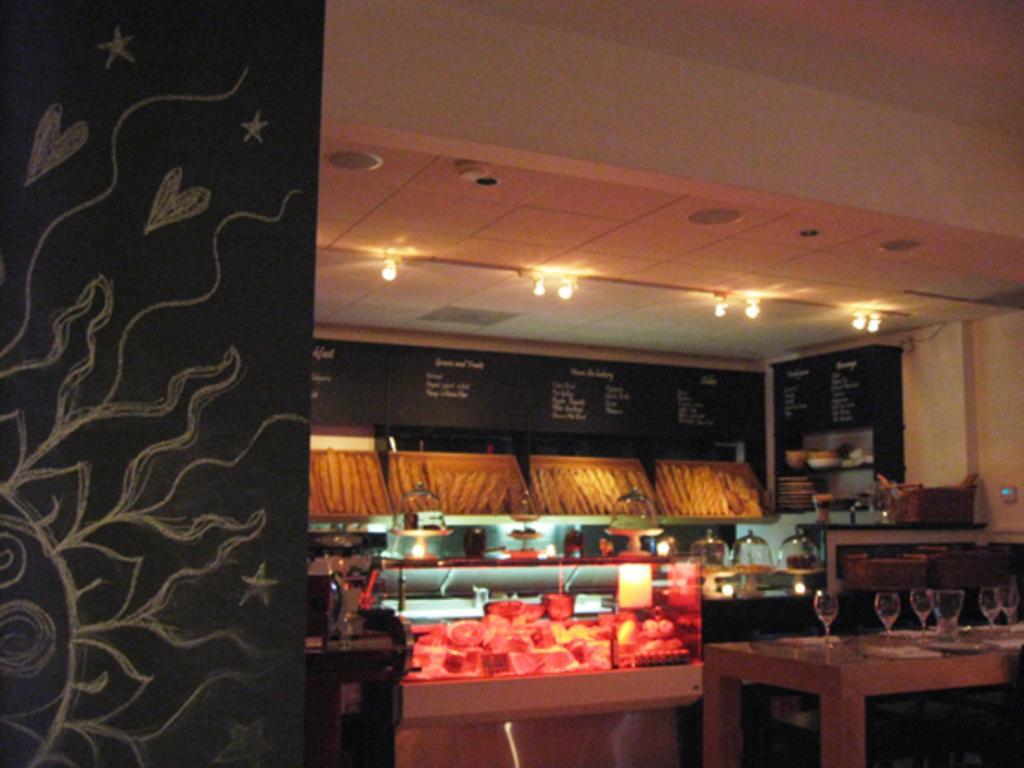Describe this image in one or two sentences. In this image we can see the wall on which we can see some art. Here we can see glasses are kept on a table, we can see some objects, boards and the ceiling lights in the background. 